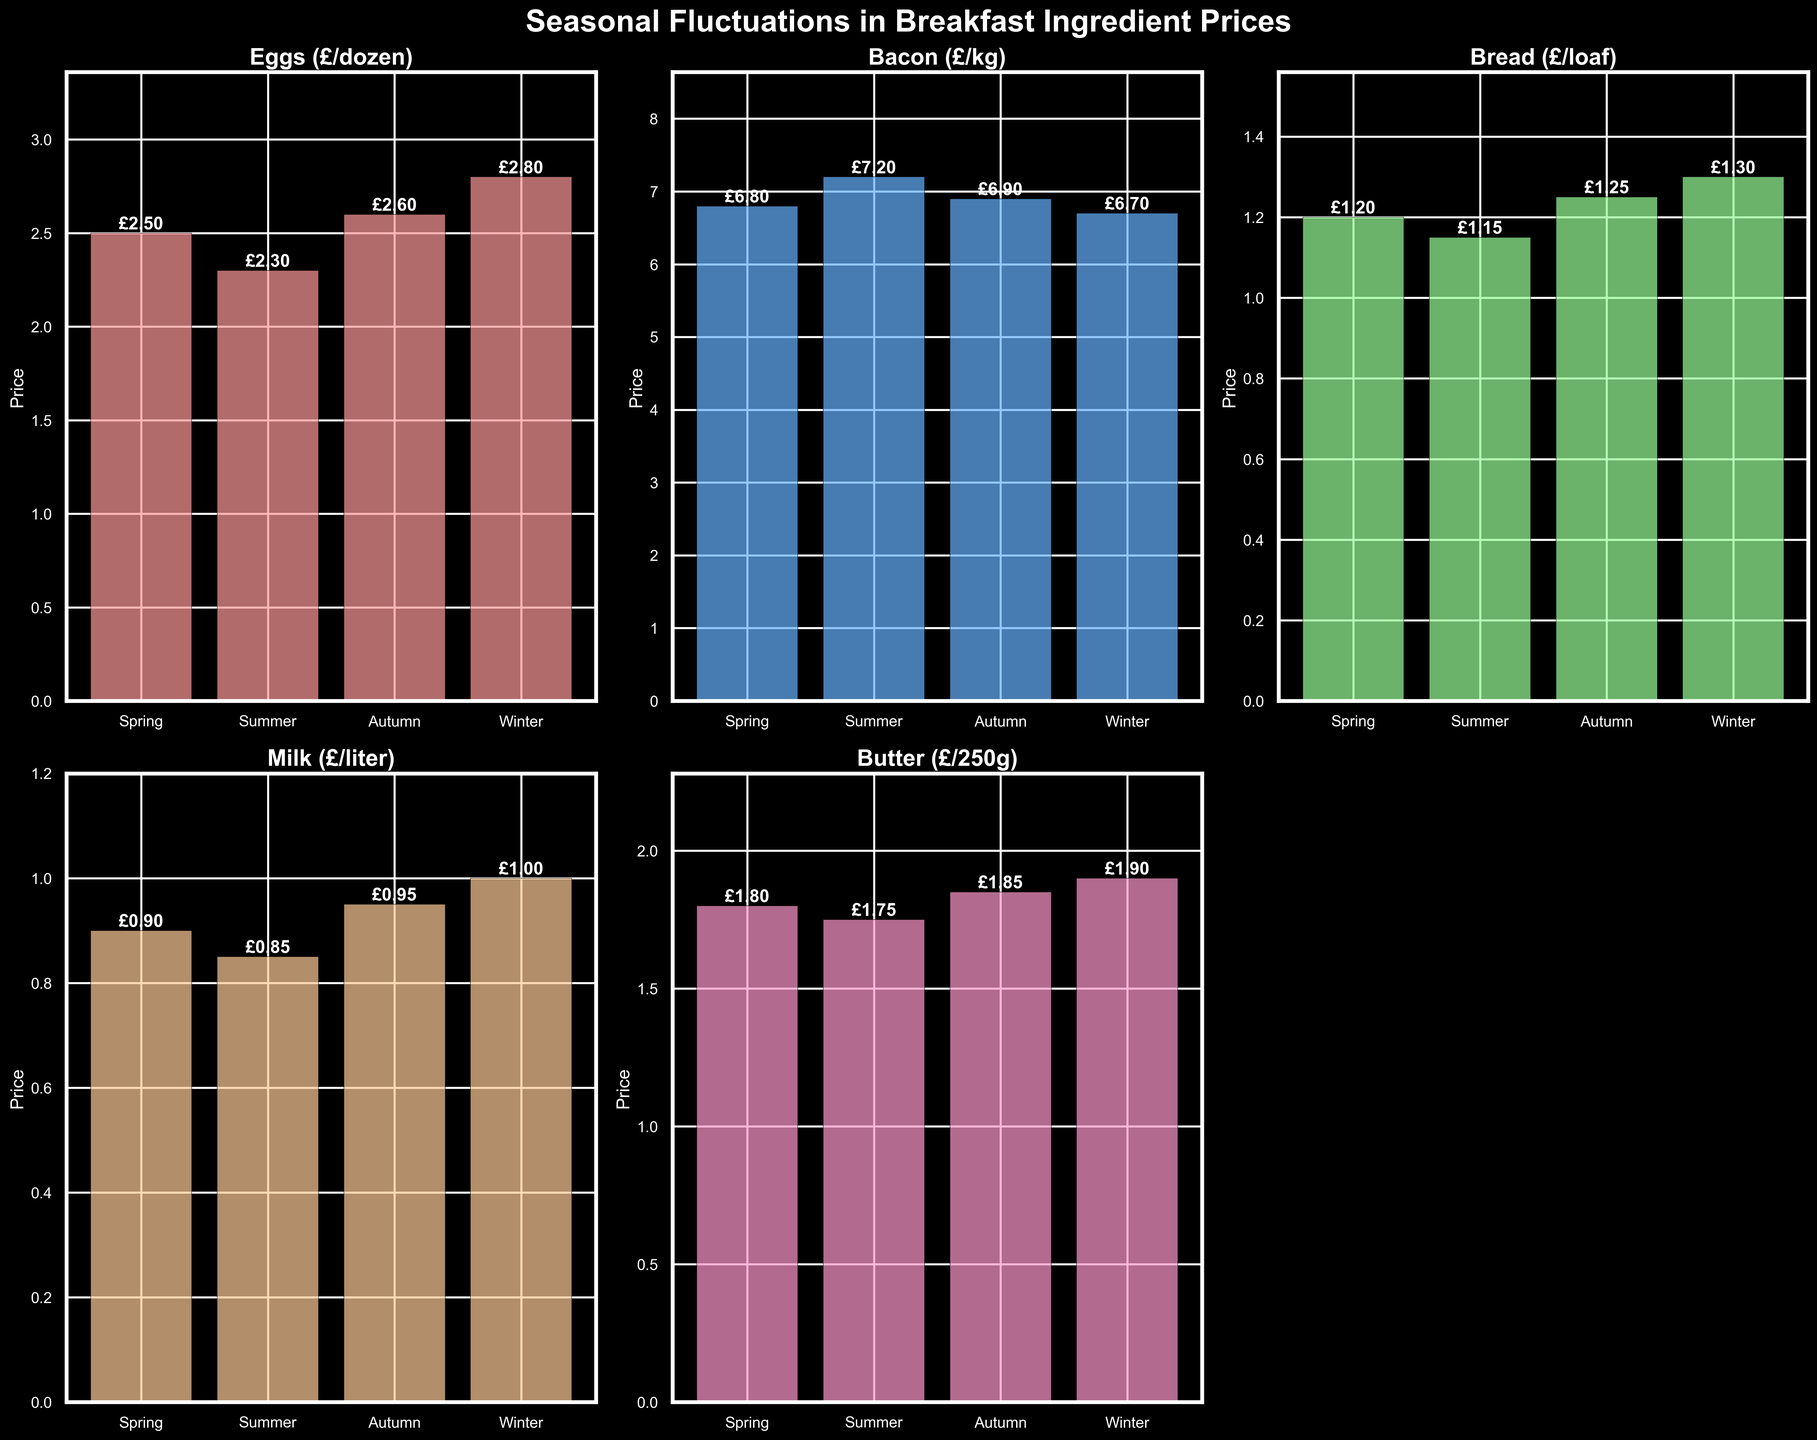How many subplots are visible in the figure? There are 2 rows and 3 columns of subplots, creating a total of 6 subplots. However, one subplot in the bottom-right corner has been turned off, so you see 5 subplots.
Answer: 5 Which ingredient has the highest price in Winter? Look at the Winter column for all ingredients and identify the highest price. Eggs (£/dozen) is £2.80, Bacon (£/kg) is £6.70, Bread (£/loaf) is £1.30, Milk (£/liter) is £1.00, Butter (£/250g) is £1.90. The highest price is Bacon at £6.70.
Answer: Bacon (£/kg) What is the difference between the price of Eggs in Winter and Summer? Find the price of Eggs in Winter (£2.80) and in Summer (£2.30). Then, subtract the Summer price from the Winter price: £2.80 - £2.30 = £0.50.
Answer: £0.50 Which ingredient shows the smallest seasonal fluctuation in price? Calculate the range (difference between max and min) for each ingredient. Eggs range: £2.80 - £2.30 = £0.50, Bacon range: £7.20 - £6.70 = £0.50, Bread range: £1.30 - £1.15 = £0.15, Milk range: £1.00 - £0.85 = £0.15, Butter range: £1.90 - £1.75 = £0.15. The smallest fluctuation is shared by Bread, Milk, and Butter, all at £0.15.
Answer: Bread, Milk, Butter Which season has the overall highest average price for all ingredients combined? Calculate the average price for each season: 
Spring: (2.50 + 6.80 + 1.20 + 0.90 + 1.80)/5 = 2.64,
Summer: (2.30 + 7.20 + 1.15 + 0.85 + 1.75)/5 = 2.65,
Autumn: (2.60 + 6.90 + 1.25 + 0.95 + 1.85)/5 = 2.71,
Winter: (2.80 + 6.70 + 1.30 + 1.00 + 1.90)/5 = 2.74.
Autumn has the highest average price.
Answer: Autumn .Compare the prices of Milk and Butter in Summer. Which is more expensive? Look at the Summer prices for Milk and Butter. Milk is £0.85, and Butter is £1.75. Butter is more expensive.
Answer: Butter What is the overall trend of Bacon prices across the seasons? Observe the Bacon prices across all seasons. They are Spring (£6.80), Summer (£7.20), Autumn (£6.90), and Winter (£6.70). The trend is an increase in Summer and then a general decline.
Answer: Increasing in Summer, then decreasing By how much does the price of Bread increase from Spring to Winter? Find the price of Bread in Spring (£1.20) and in Winter (£1.30). Then, subtract the Spring price from the Winter price: £1.30 - £1.20 = £0.10.
Answer: £0.10 Which season has the lowest price for Eggs? Compare the prices of Eggs in all seasons: Spring (£2.50), Summer (£2.30), Autumn (£2.60), and Winter (£2.80). The lowest price is in Summer at £2.30.
Answer: Summer 